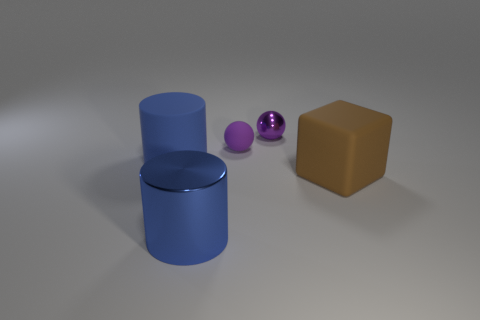The big blue thing behind the large object that is to the right of the purple ball in front of the small purple shiny thing is made of what material?
Make the answer very short. Rubber. Is the metallic cylinder the same size as the purple matte object?
Provide a succinct answer. No. What is the big brown object made of?
Offer a terse response. Rubber. There is another object that is the same color as the tiny rubber thing; what is its material?
Your response must be concise. Metal. There is a shiny object that is behind the small rubber sphere; does it have the same shape as the small purple rubber thing?
Offer a terse response. Yes. What number of objects are yellow objects or small spheres?
Your answer should be very brief. 2. Is the large blue cylinder in front of the large blue matte cylinder made of the same material as the big brown cube?
Provide a succinct answer. No. What size is the purple shiny ball?
Offer a very short reply. Small. There is another tiny thing that is the same color as the small shiny object; what is its shape?
Your response must be concise. Sphere. How many cubes are big blue metallic objects or small things?
Your answer should be very brief. 0. 